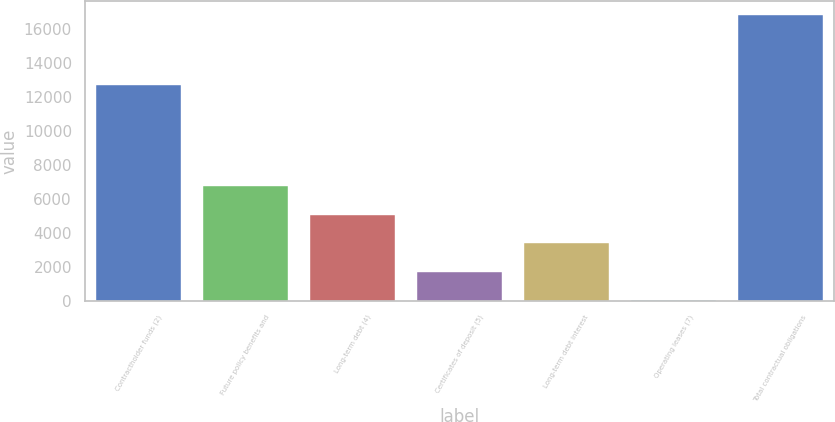Convert chart to OTSL. <chart><loc_0><loc_0><loc_500><loc_500><bar_chart><fcel>Contractholder funds (2)<fcel>Future policy benefits and<fcel>Long-term debt (4)<fcel>Certificates of deposit (5)<fcel>Long-term debt interest<fcel>Operating leases (7)<fcel>Total contractual obligations<nl><fcel>12718.7<fcel>6747.98<fcel>5070.81<fcel>1716.47<fcel>3393.64<fcel>39.3<fcel>16811<nl></chart> 